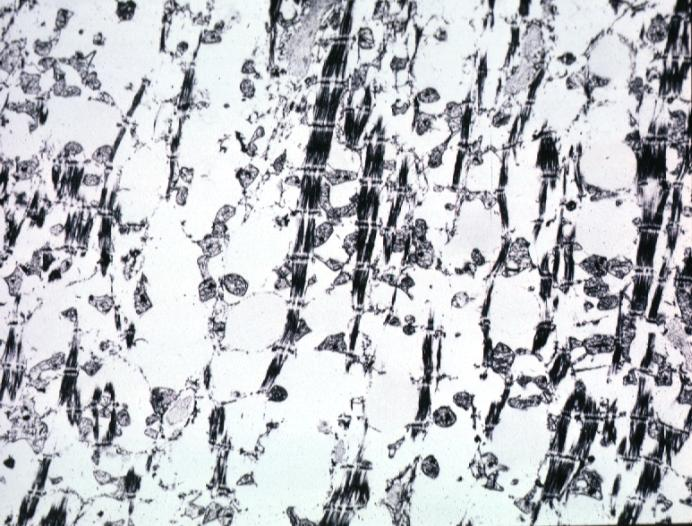where is this?
Answer the question using a single word or phrase. Heart 